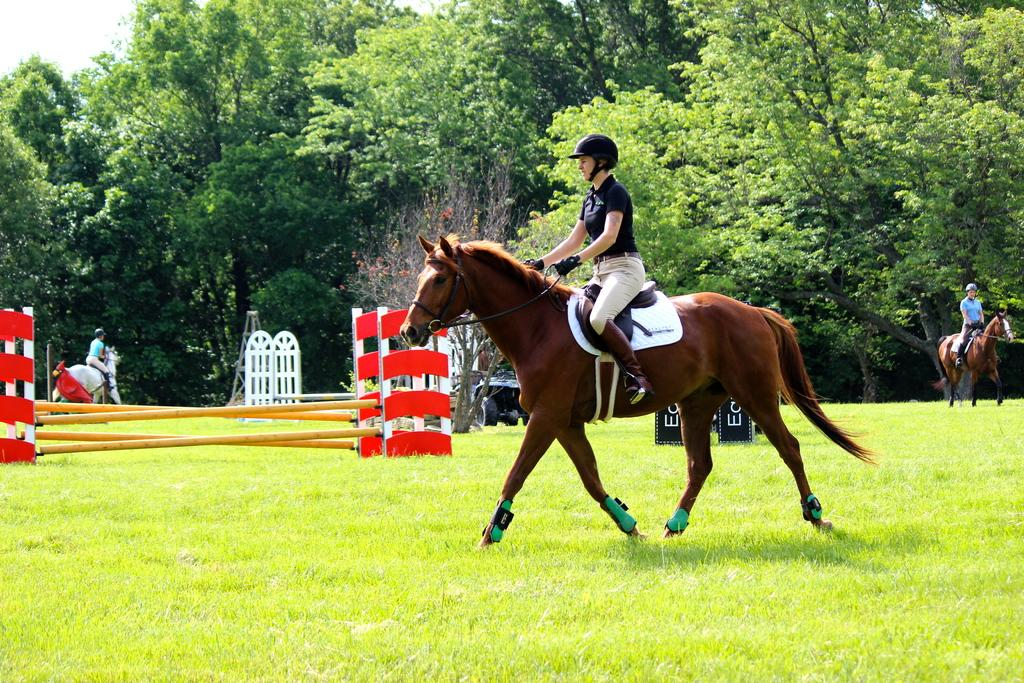What are the people in the image doing? The people in the image are riding horses. What obstacles are present for the people riding horses? There are hurdles around the people riding horses. What else can be seen in the image besides the people and horses? There are other objects present in the image. What can be seen in the distance in the image? There are trees visible in the background of the image. What is the level of disgust expressed by the people in the image? There is no indication of disgust in the image; the people are riding horses and navigating hurdles. What list is being referenced in the image? There is no list present in the image. 